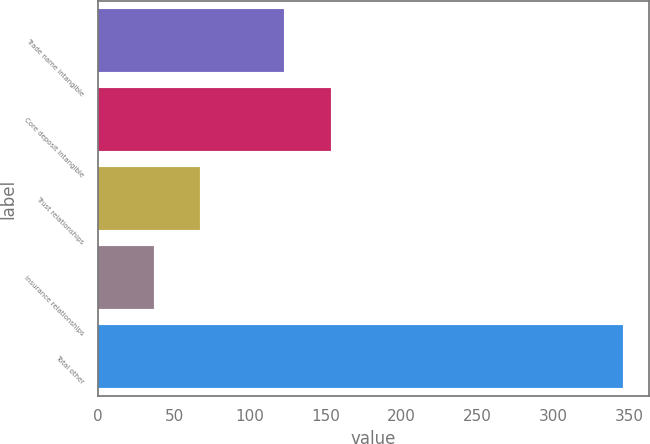Convert chart to OTSL. <chart><loc_0><loc_0><loc_500><loc_500><bar_chart><fcel>Trade name intangible<fcel>Core deposit intangible<fcel>Trust relationships<fcel>Insurance relationships<fcel>Total other<nl><fcel>122.7<fcel>153.62<fcel>67.42<fcel>36.5<fcel>345.7<nl></chart> 